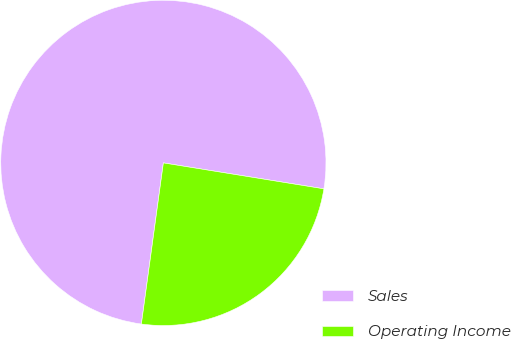<chart> <loc_0><loc_0><loc_500><loc_500><pie_chart><fcel>Sales<fcel>Operating Income<nl><fcel>75.39%<fcel>24.61%<nl></chart> 